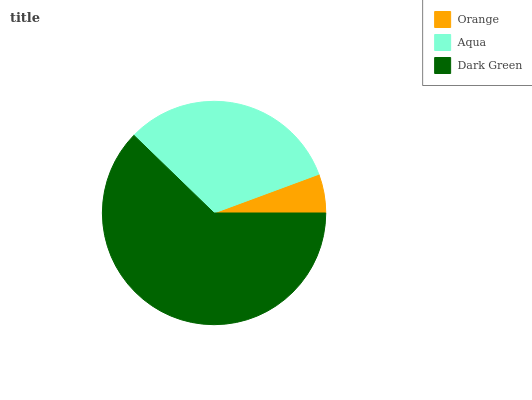Is Orange the minimum?
Answer yes or no. Yes. Is Dark Green the maximum?
Answer yes or no. Yes. Is Aqua the minimum?
Answer yes or no. No. Is Aqua the maximum?
Answer yes or no. No. Is Aqua greater than Orange?
Answer yes or no. Yes. Is Orange less than Aqua?
Answer yes or no. Yes. Is Orange greater than Aqua?
Answer yes or no. No. Is Aqua less than Orange?
Answer yes or no. No. Is Aqua the high median?
Answer yes or no. Yes. Is Aqua the low median?
Answer yes or no. Yes. Is Orange the high median?
Answer yes or no. No. Is Orange the low median?
Answer yes or no. No. 